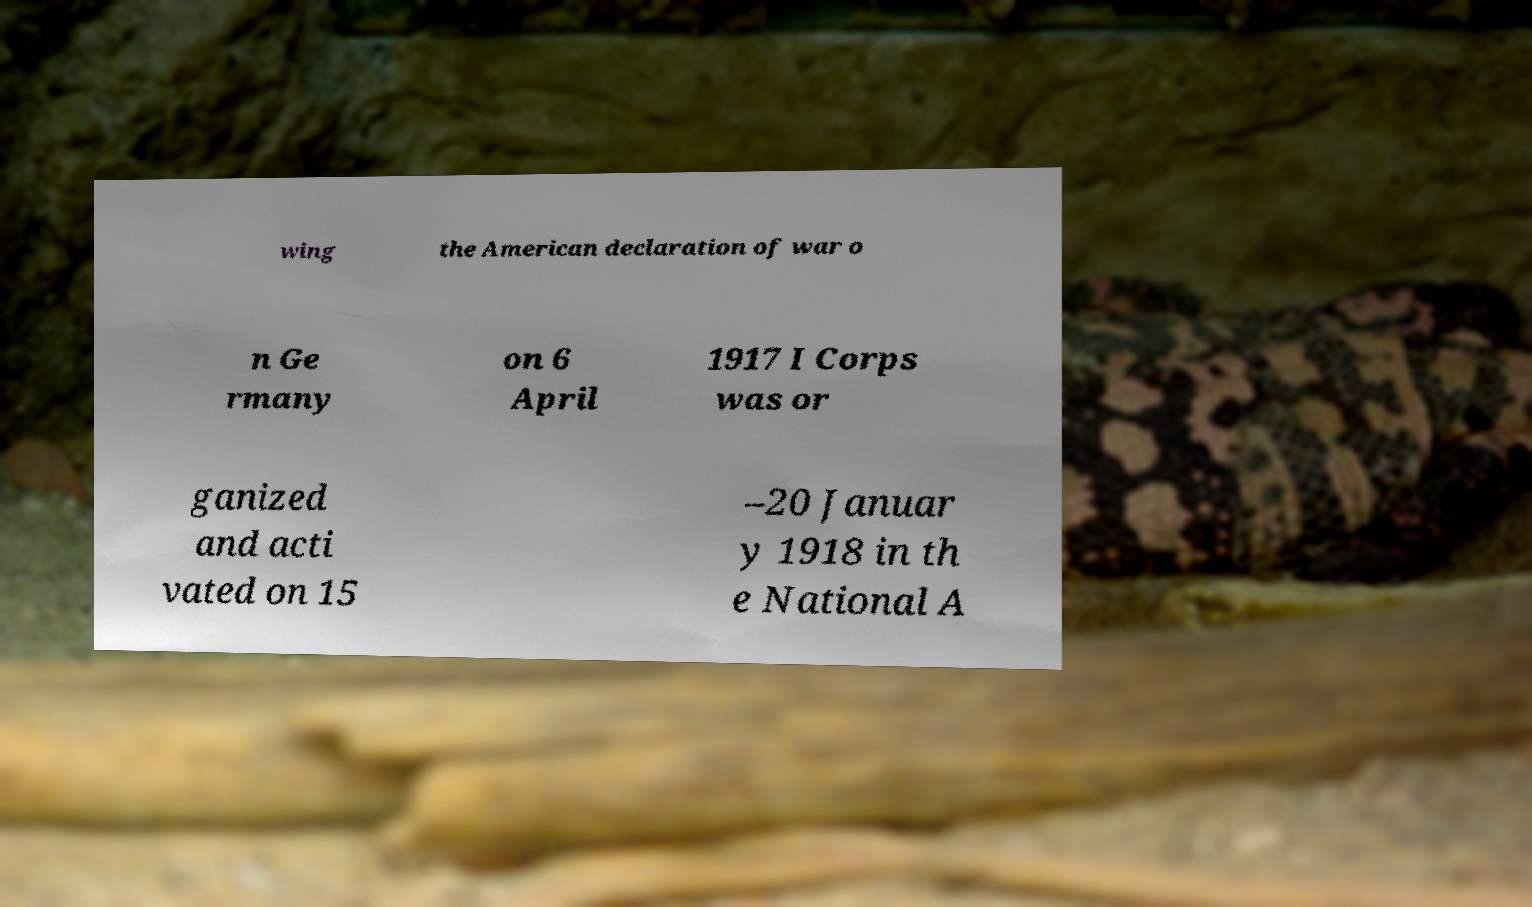Could you assist in decoding the text presented in this image and type it out clearly? wing the American declaration of war o n Ge rmany on 6 April 1917 I Corps was or ganized and acti vated on 15 –20 Januar y 1918 in th e National A 